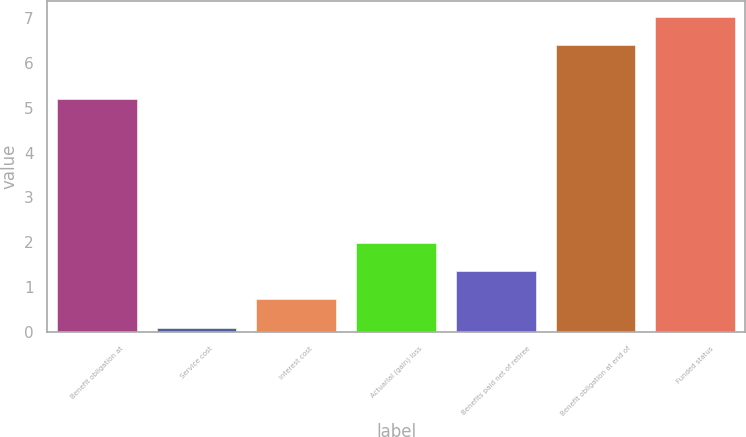Convert chart. <chart><loc_0><loc_0><loc_500><loc_500><bar_chart><fcel>Benefit obligation at<fcel>Service cost<fcel>Interest cost<fcel>Actuarial (gain) loss<fcel>Benefits paid net of retiree<fcel>Benefit obligation at end of<fcel>Funded status<nl><fcel>5.2<fcel>0.1<fcel>0.73<fcel>1.99<fcel>1.36<fcel>6.4<fcel>7.03<nl></chart> 